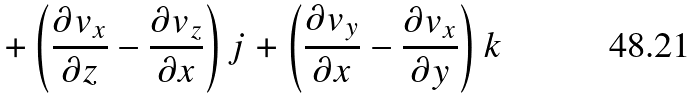<formula> <loc_0><loc_0><loc_500><loc_500>+ \left ( { \frac { \partial v _ { x } } { \partial z } } - { \frac { \partial v _ { z } } { \partial x } } \right ) j + \left ( { \frac { \partial v _ { y } } { \partial x } } - { \frac { \partial v _ { x } } { \partial y } } \right ) k</formula> 